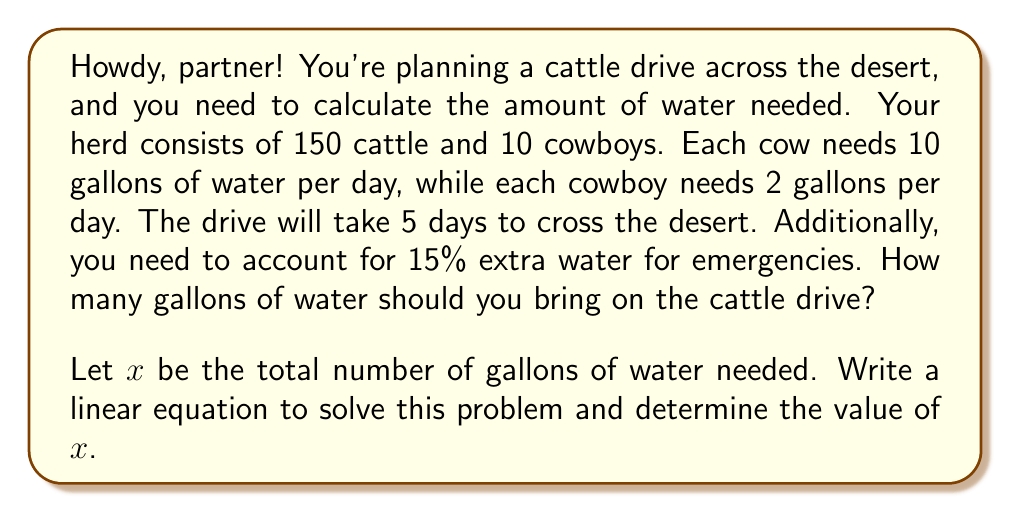Teach me how to tackle this problem. Let's break this down step-by-step, partner:

1) First, let's calculate the daily water needs:
   - For cattle: 150 cows × 10 gallons = 1500 gallons per day
   - For cowboys: 10 cowboys × 2 gallons = 20 gallons per day
   - Total daily water need: 1500 + 20 = 1520 gallons

2) Now, we need to account for the 5-day journey:
   1520 gallons × 5 days = 7600 gallons

3) We're not done yet! We need to add 15% for emergencies. Let's set up our equation:
   
   $$x = 7600 + 0.15x$$

   Where $x$ is the total amount of water needed, including the 15% extra.

4) Let's solve this equation:
   $$x - 0.15x = 7600$$
   $$0.85x = 7600$$
   $$x = \frac{7600}{0.85} = 8941.18$$

5) Since we can't bring a fraction of a gallon, we'll round up to the nearest whole number.
Answer: The total amount of water needed for the cattle drive is 8942 gallons. 